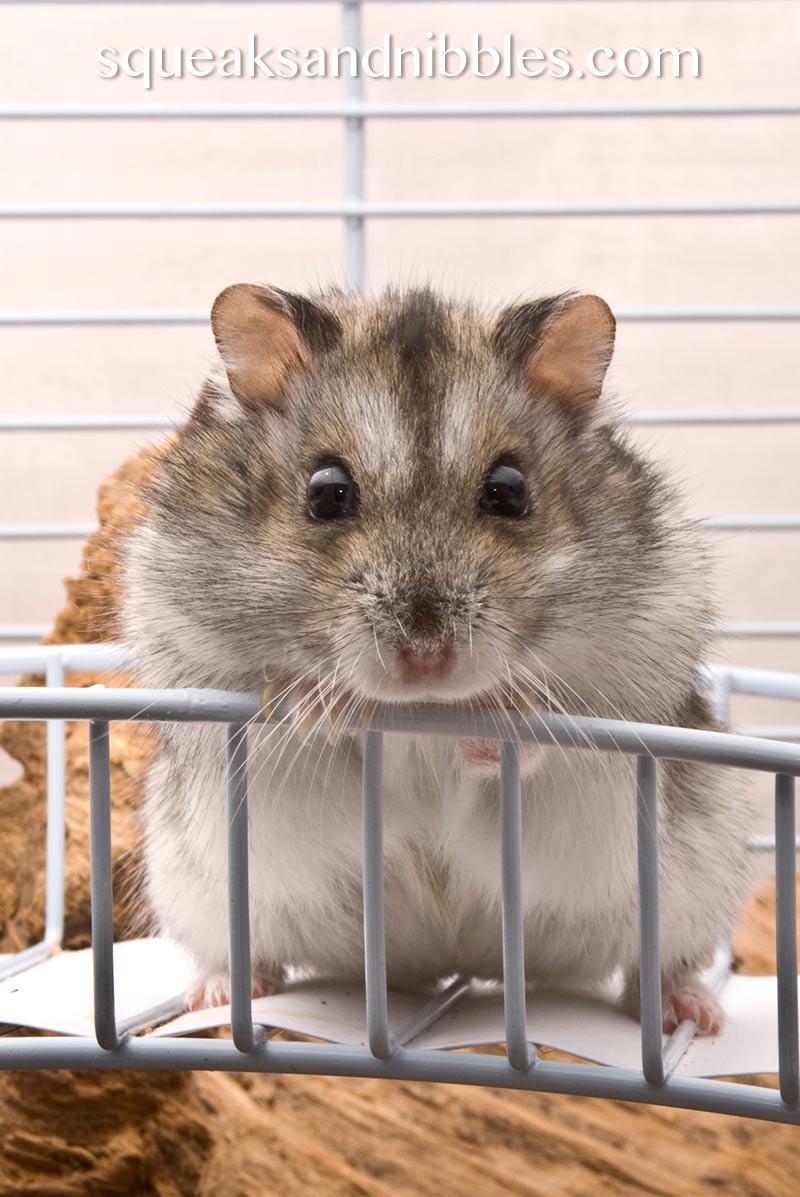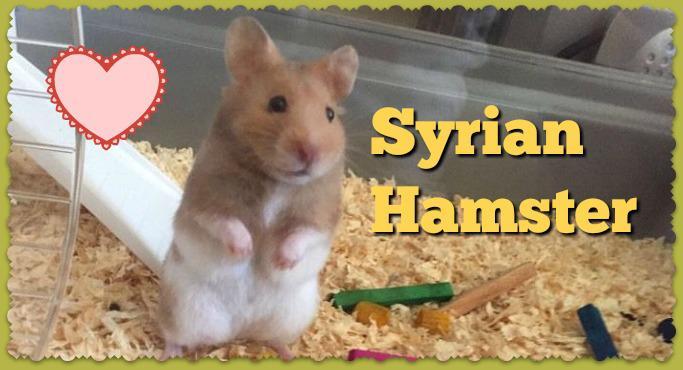The first image is the image on the left, the second image is the image on the right. Considering the images on both sides, is "The left image contains at least seven rodents." valid? Answer yes or no. No. The first image is the image on the left, the second image is the image on the right. For the images shown, is this caption "At least one animal is outside." true? Answer yes or no. No. 